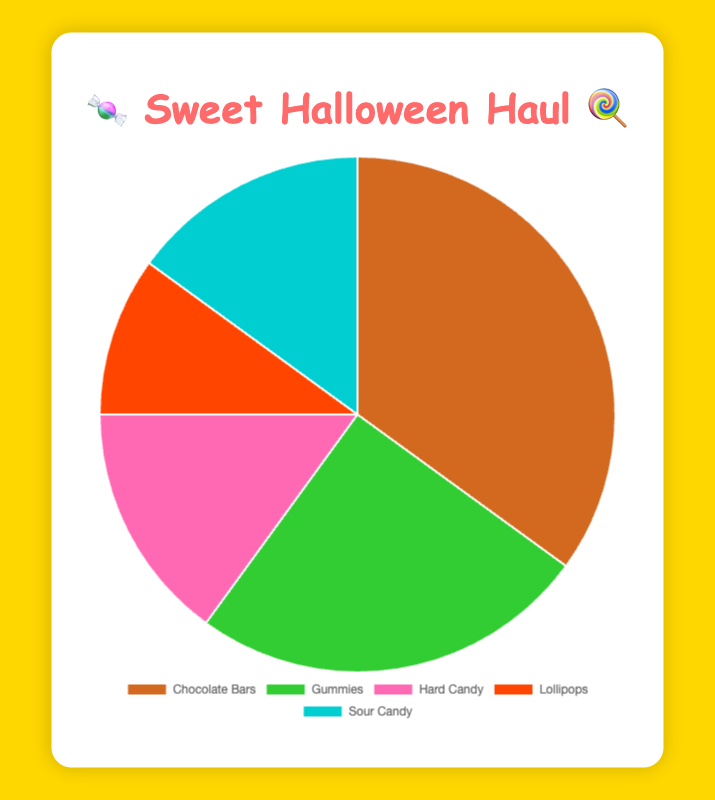What's the most popular type of candy from Halloween hauls? The pie chart shows the different types of candy and their corresponding percentages. The largest portion of the pie chart, labeled "Chocolate Bars," takes up 35%, making it the most popular.
Answer: Chocolate Bars Which two types of candy are equally preferred? By examining the pie chart, two segments each have 15% of the entire pie, labeled "Hard Candy" and "Sour Candy." Therefore, they are equally preferred.
Answer: Hard Candy and Sour Candy What is the difference in preference between Chocolate Bars and Gummies? According to the pie chart, Chocolate Bars have a preference of 35% and Gummies have a preference of 25%. The difference is 35% - 25% = 10%.
Answer: 10% Which type of candy has the smallest percentage of preference? Observing the pie chart, the smallest segment is labeled "Lollipops," constituting 10% of the total.
Answer: Lollipops If we combine the preferences for Hard Candy and Lollipops, what percentage of the total do they represent? The pie chart shows that Hard Candy is 15% and Lollipops is 10%. Adding these together gives 15% + 10% = 25%.
Answer: 25% Among the displayed types of candy, which is the second most preferred and what is its favorite example? The second largest segment of the pie chart represents Gummies, with a preference of 25%. The additional information specifies their favorite example as "Haribo Goldbears."
Answer: Gummies, Haribo Goldbears Which type of candy has the third largest preference and what color is it represented by? The third largest segment in the pie chart is "Hard Candy," which makes up 15%. The segment is colored pink.
Answer: Hard Candy, pink How much more popular are Chocolate Bars compared to Lollipops? Checking each section of the pie chart, Chocolate Bars have a preference of 35%, and Lollipops have a preference of 10%. The difference is 35% - 10% = 25%.
Answer: 25% What percentage of the total preferences is represented by sour and hard candies together, and what are their favorite examples? The pie chart displays Sour Candy and Hard Candy, each at 15%. Combined, they total 15% + 15% = 30%. The favorite examples provided are "Warheads" for Sour Candy and "Jolly Ranchers" for Hard Candy.
Answer: 30%, Warheads and Jolly Ranchers 